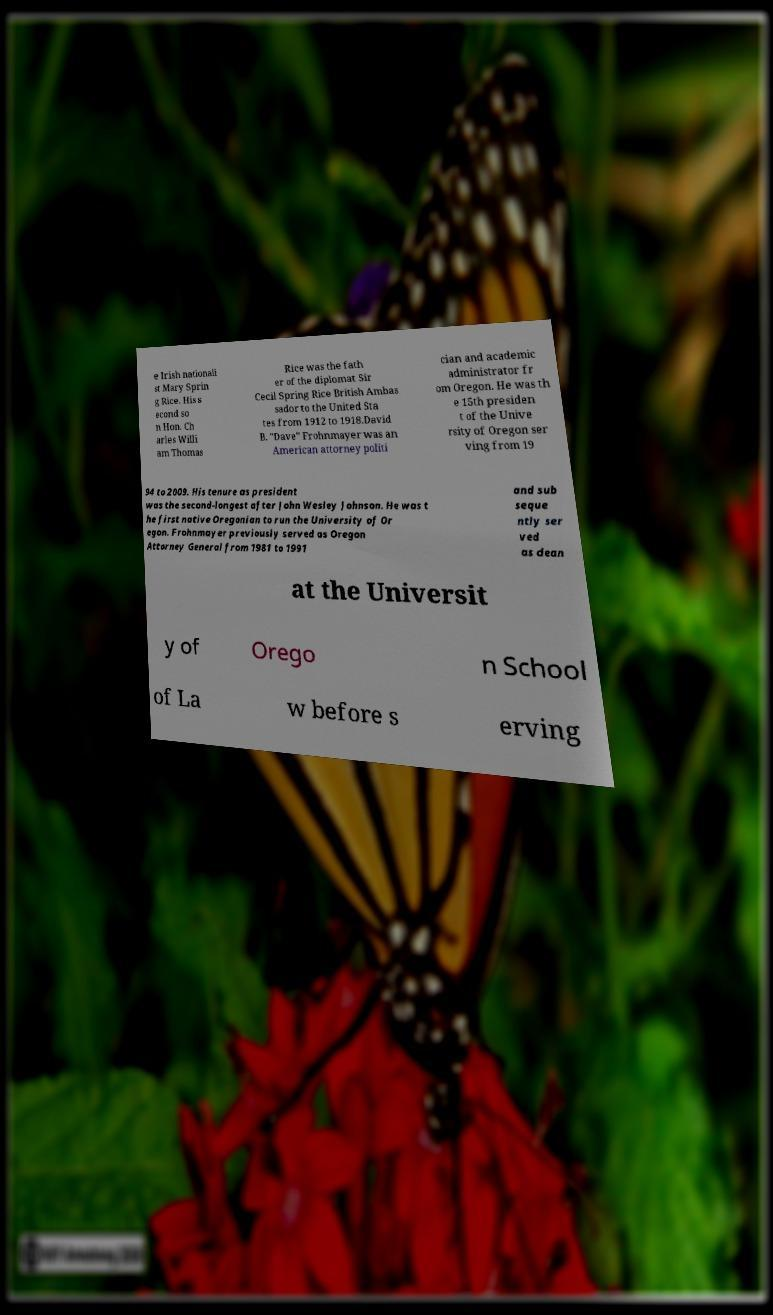Can you accurately transcribe the text from the provided image for me? e Irish nationali st Mary Sprin g Rice. His s econd so n Hon. Ch arles Willi am Thomas Rice was the fath er of the diplomat Sir Cecil Spring Rice British Ambas sador to the United Sta tes from 1912 to 1918.David B. "Dave" Frohnmayer was an American attorney politi cian and academic administrator fr om Oregon. He was th e 15th presiden t of the Unive rsity of Oregon ser ving from 19 94 to 2009. His tenure as president was the second-longest after John Wesley Johnson. He was t he first native Oregonian to run the University of Or egon. Frohnmayer previously served as Oregon Attorney General from 1981 to 1991 and sub seque ntly ser ved as dean at the Universit y of Orego n School of La w before s erving 